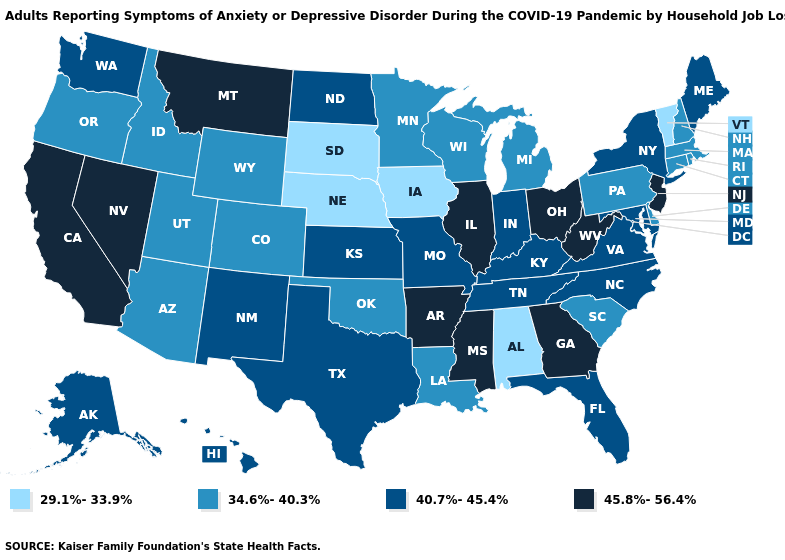Among the states that border South Dakota , does Nebraska have the lowest value?
Short answer required. Yes. Is the legend a continuous bar?
Short answer required. No. Name the states that have a value in the range 34.6%-40.3%?
Concise answer only. Arizona, Colorado, Connecticut, Delaware, Idaho, Louisiana, Massachusetts, Michigan, Minnesota, New Hampshire, Oklahoma, Oregon, Pennsylvania, Rhode Island, South Carolina, Utah, Wisconsin, Wyoming. How many symbols are there in the legend?
Short answer required. 4. What is the lowest value in the USA?
Keep it brief. 29.1%-33.9%. What is the highest value in states that border Delaware?
Be succinct. 45.8%-56.4%. Among the states that border New Mexico , which have the lowest value?
Quick response, please. Arizona, Colorado, Oklahoma, Utah. Does Michigan have the lowest value in the MidWest?
Write a very short answer. No. Which states hav the highest value in the South?
Write a very short answer. Arkansas, Georgia, Mississippi, West Virginia. What is the highest value in states that border Washington?
Answer briefly. 34.6%-40.3%. Does New Mexico have the highest value in the USA?
Give a very brief answer. No. Is the legend a continuous bar?
Keep it brief. No. Among the states that border Washington , which have the lowest value?
Keep it brief. Idaho, Oregon. What is the value of Michigan?
Keep it brief. 34.6%-40.3%. Name the states that have a value in the range 45.8%-56.4%?
Short answer required. Arkansas, California, Georgia, Illinois, Mississippi, Montana, Nevada, New Jersey, Ohio, West Virginia. 